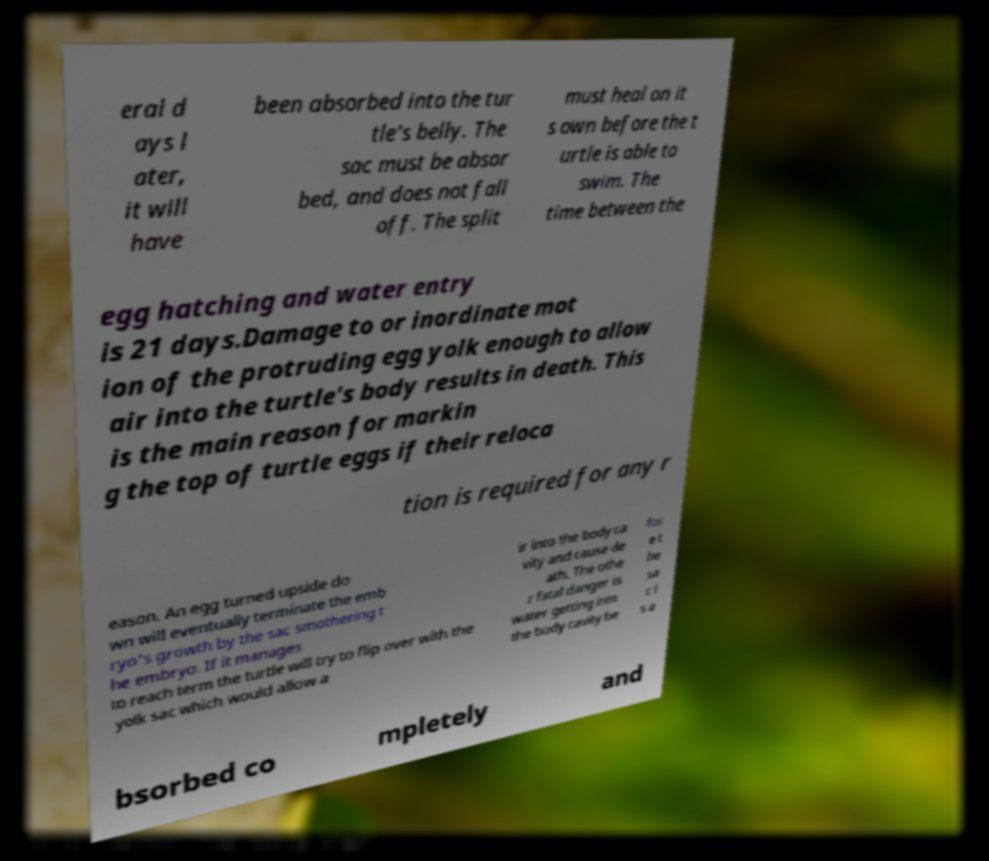Could you assist in decoding the text presented in this image and type it out clearly? eral d ays l ater, it will have been absorbed into the tur tle's belly. The sac must be absor bed, and does not fall off. The split must heal on it s own before the t urtle is able to swim. The time between the egg hatching and water entry is 21 days.Damage to or inordinate mot ion of the protruding egg yolk enough to allow air into the turtle's body results in death. This is the main reason for markin g the top of turtle eggs if their reloca tion is required for any r eason. An egg turned upside do wn will eventually terminate the emb ryo's growth by the sac smothering t he embryo. If it manages to reach term the turtle will try to flip over with the yolk sac which would allow a ir into the body ca vity and cause de ath. The othe r fatal danger is water getting into the body cavity be for e t he sa c i s a bsorbed co mpletely and 